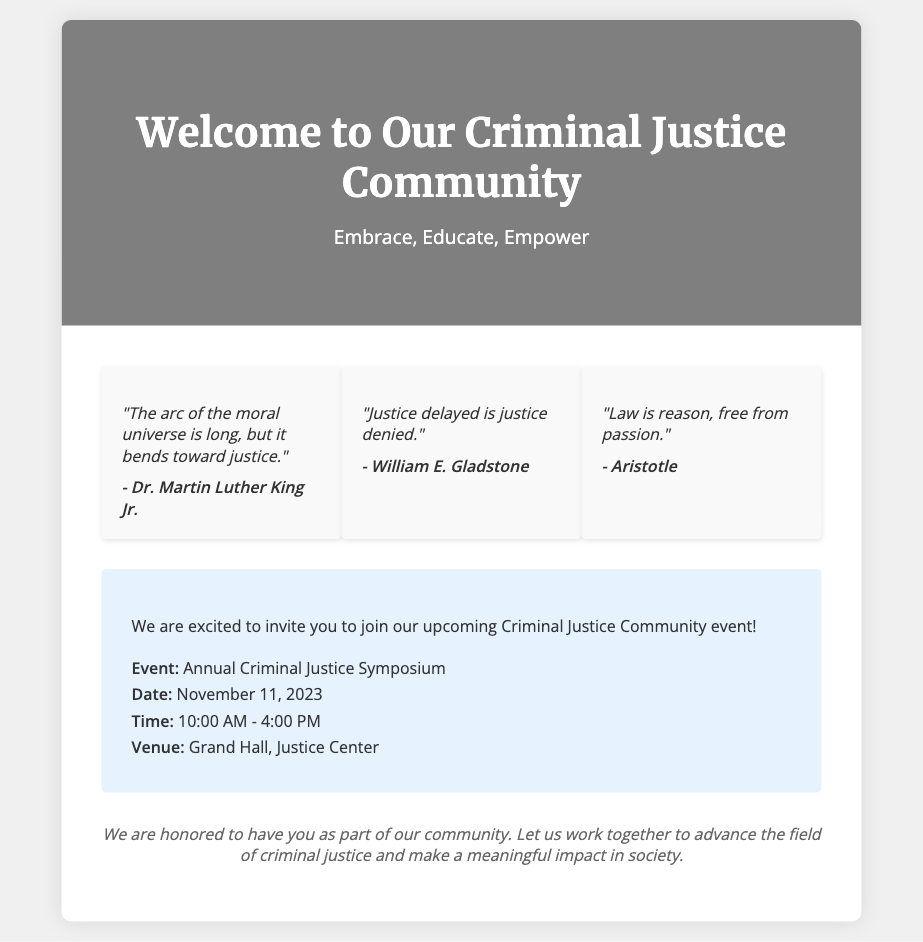What is the title of the card? The title of the card is prominently displayed at the top and serves as the main heading of the document.
Answer: Welcome to Our Criminal Justice Community Who is quoted in the first quote? The first quote in the quotes section attributes the statement to a notable figure known for his role in civil rights.
Answer: Dr. Martin Luther King Jr What is the date of the upcoming event? The event details section specifies an important date for the community event.
Answer: November 11, 2023 How long is the Annual Criminal Justice Symposium scheduled for? The time section provides a clear start and end time for the event.
Answer: 6 hours What is the venue of the event? The venue details indicate where the upcoming symposium will take place, which is an essential piece of information for attendees.
Answer: Grand Hall, Justice Center What is the main message conveyed at the end of the card? The closing message encapsulates the essence of community within the context of advancing criminal justice.
Answer: We are honored to have you as part of our community What do the three quotes primarily discuss? The quotes collectively reflect significant themes related to justice, morality, and law.
Answer: Justice What invitation is extended in the card? The document includes an invitation that encourages participation in a community gathering related to criminal justice.
Answer: Join our upcoming Criminal Justice Community event! 